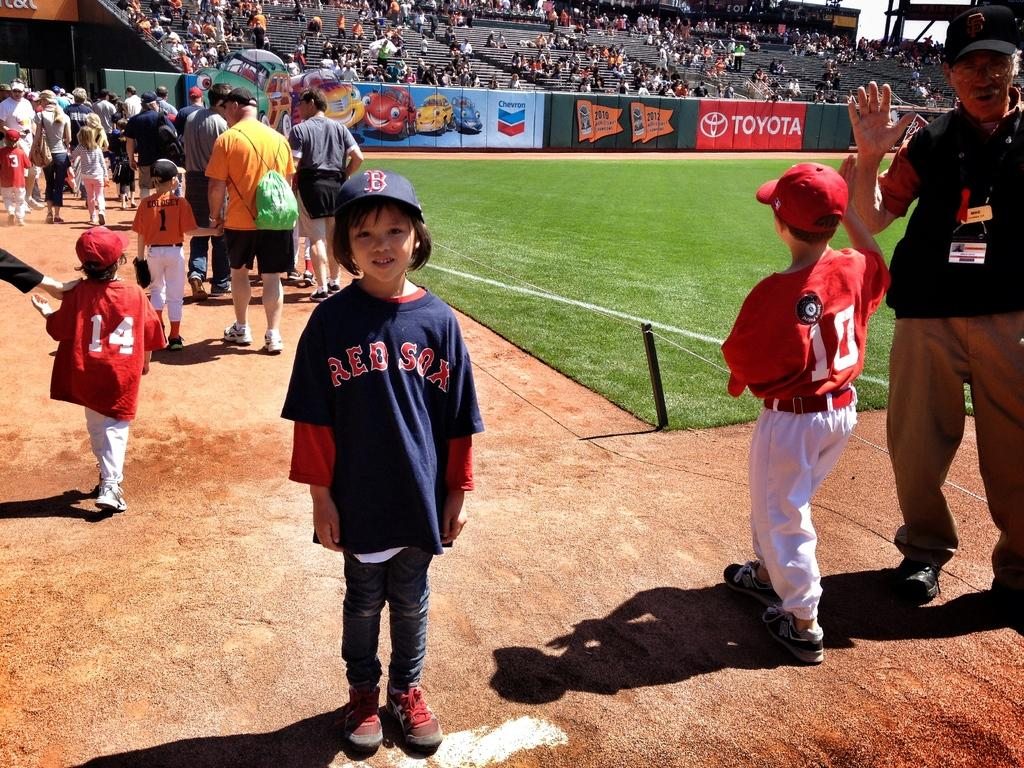<image>
Summarize the visual content of the image. A girl is wearing a Red Sox jersey and is posing for a picture on a baseball field. 